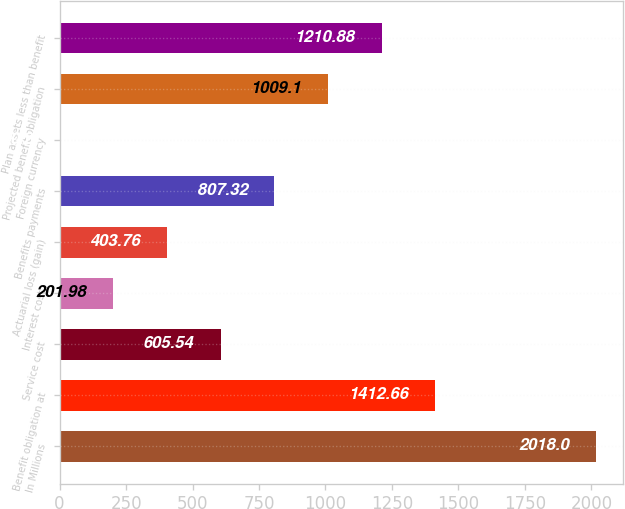<chart> <loc_0><loc_0><loc_500><loc_500><bar_chart><fcel>In Millions<fcel>Benefit obligation at<fcel>Service cost<fcel>Interest cost<fcel>Actuarial loss (gain)<fcel>Benefits payments<fcel>Foreign currency<fcel>Projected benefit obligation<fcel>Plan assets less than benefit<nl><fcel>2018<fcel>1412.66<fcel>605.54<fcel>201.98<fcel>403.76<fcel>807.32<fcel>0.2<fcel>1009.1<fcel>1210.88<nl></chart> 